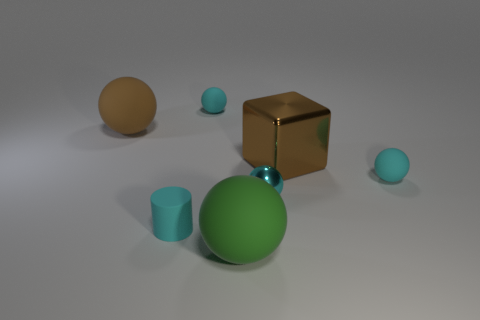How many rubber objects are tiny brown cylinders or cyan things?
Provide a succinct answer. 3. How many tiny cylinders are behind the tiny cyan sphere to the left of the tiny shiny sphere that is behind the green object?
Offer a very short reply. 0. There is a green ball that is the same material as the cylinder; what size is it?
Your response must be concise. Large. What number of things are the same color as the tiny cylinder?
Ensure brevity in your answer.  3. There is a cyan rubber ball that is right of the green thing; is its size the same as the large brown metallic object?
Ensure brevity in your answer.  No. What is the color of the sphere that is behind the tiny metallic sphere and right of the green rubber sphere?
Your response must be concise. Cyan. What number of objects are either tiny brown balls or spheres behind the large brown sphere?
Your answer should be compact. 1. There is a cyan cylinder that is on the right side of the rubber ball left of the thing behind the brown rubber object; what is it made of?
Offer a very short reply. Rubber. Are there any other things that have the same material as the brown ball?
Ensure brevity in your answer.  Yes. Is the color of the big matte ball that is behind the large shiny object the same as the cube?
Offer a terse response. Yes. 